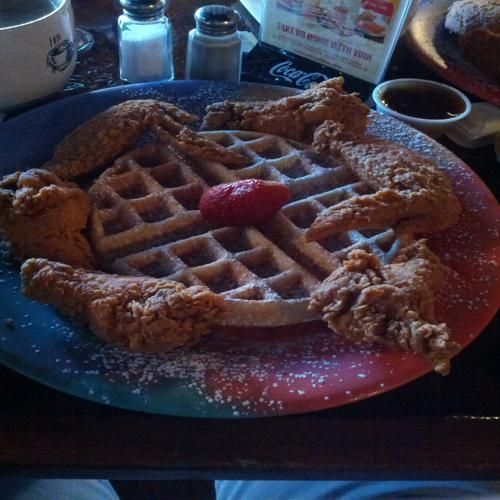What kind of meal is shown in this image? The image displays a classic Southern American dish known as chicken and waffles, featuring crispy fried chicken served atop a warm waffle, often enjoyed with syrup or butter. 